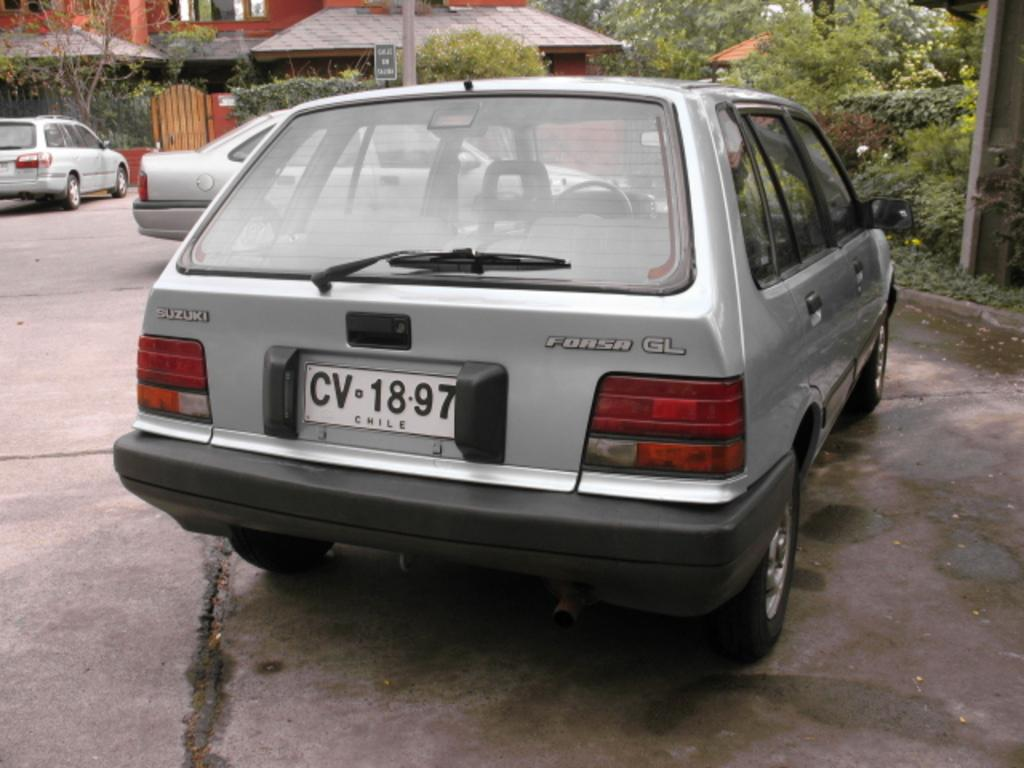<image>
Relay a brief, clear account of the picture shown. A grey Forsa GL station wagon is parked in a driveway. 